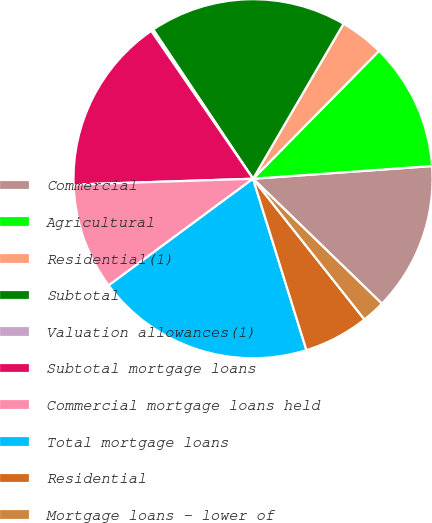Convert chart to OTSL. <chart><loc_0><loc_0><loc_500><loc_500><pie_chart><fcel>Commercial<fcel>Agricultural<fcel>Residential(1)<fcel>Subtotal<fcel>Valuation allowances(1)<fcel>Subtotal mortgage loans<fcel>Commercial mortgage loans held<fcel>Total mortgage loans<fcel>Residential<fcel>Mortgage loans - lower of<nl><fcel>13.38%<fcel>11.49%<fcel>3.97%<fcel>17.8%<fcel>0.21%<fcel>15.92%<fcel>9.61%<fcel>19.68%<fcel>5.85%<fcel>2.09%<nl></chart> 